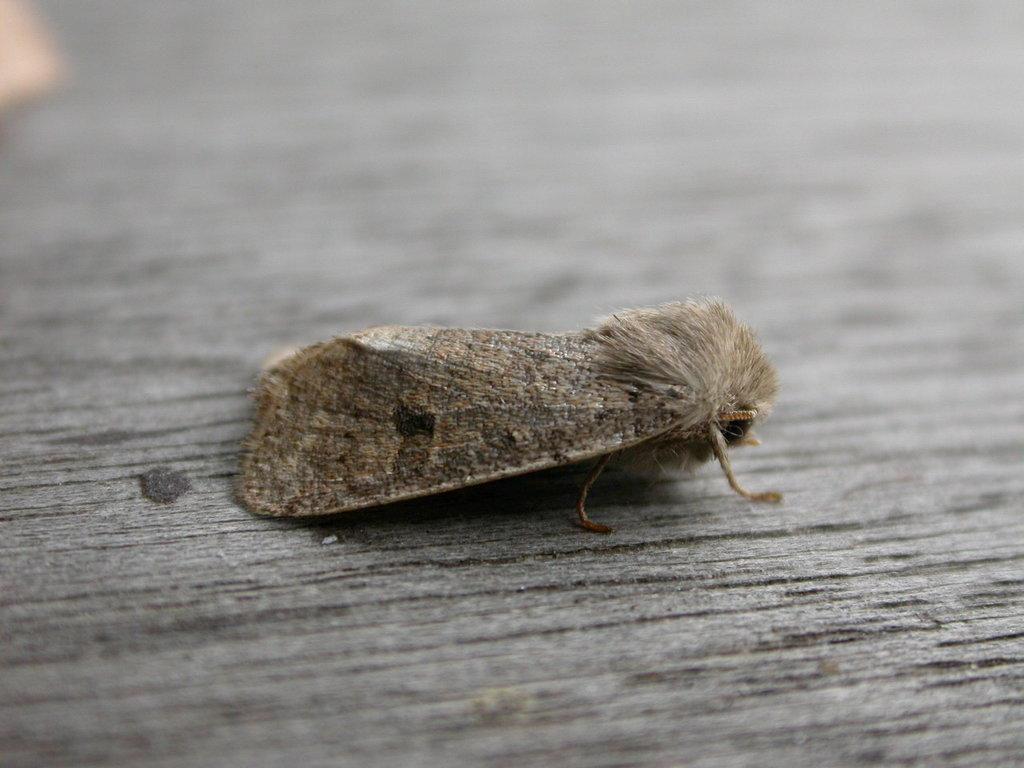What type of insect is in the image? There is a moth in the image. What surface is the moth on? The moth is on a wooden surface. Can you describe the background of the image? The background of the image is blurry. What type of fish is swimming in the image? There is no fish present in the image; it features a moth on a wooden surface. What relation does the moth have with the person in the image? There is no person present in the image, so it is not possible to determine any relation between the moth and a person. 